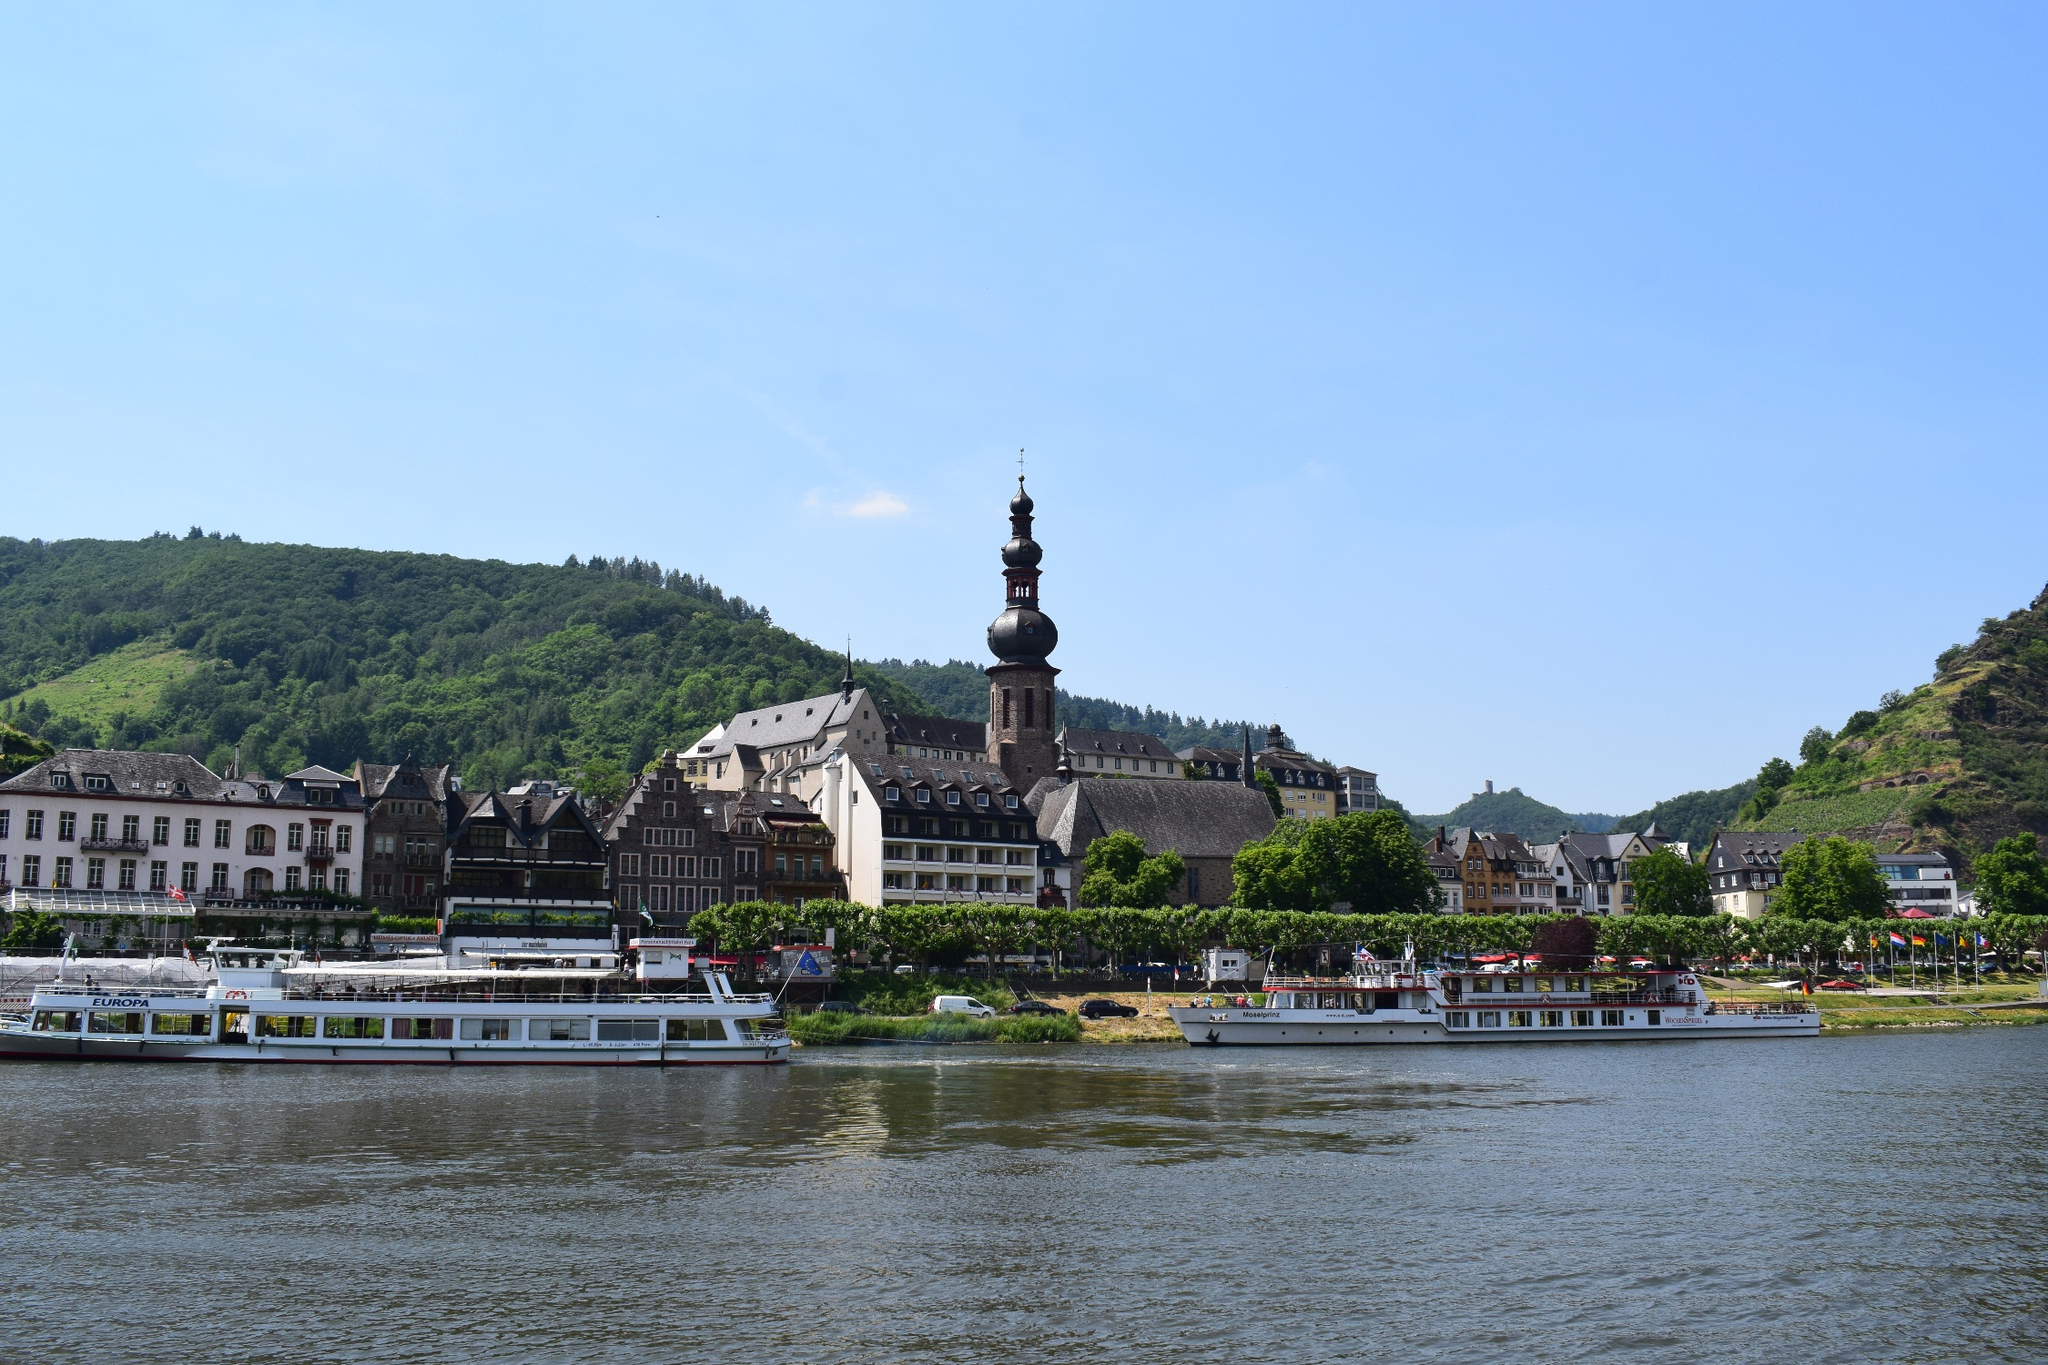Can you tell me what activities might be available in this area? In an area such as the one depicted in the image, you're likely to find a variety of activities focusing on both cultural history and natural leisure. Sightseeing tours on riverboats are a popular choice, offering visitors a unique perspective of the town's architecture and natural surroundings. The historic buildings and local landmarks make for an engaging walking tour or guided cultural experience. Depending on the specific town, there might be museums, art galleries, or workshops showcasing local crafts. Outdoor enthusiasts would appreciate the hiking trails on the verdant hills in the background, providing stunning panoramic views of the town and the river. 